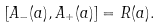<formula> <loc_0><loc_0><loc_500><loc_500>[ A _ { - } ( a ) , A _ { + } ( a ) ] = R ( a ) .</formula> 